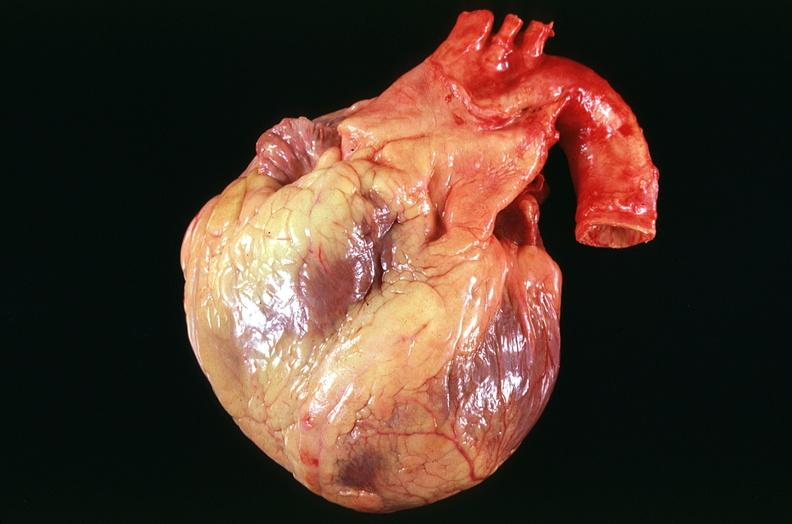what does this image show?
Answer the question using a single word or phrase. Congestive heart failure 